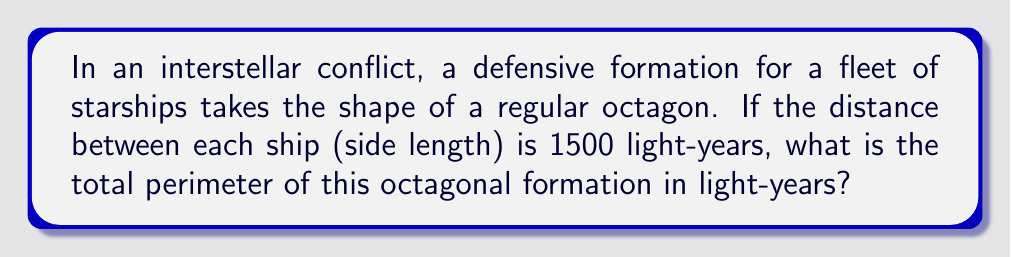Could you help me with this problem? Let's approach this step-by-step:

1) First, recall that a regular octagon has 8 equal sides.

2) The perimeter of any polygon is the sum of the lengths of all its sides.

3) For a regular polygon, we can calculate the perimeter by multiplying the length of one side by the number of sides:

   $$\text{Perimeter} = \text{Number of sides} \times \text{Side length}$$

4) In this case:
   - Number of sides = 8
   - Side length = 1500 light-years

5) Substituting these values into our formula:

   $$\text{Perimeter} = 8 \times 1500$$

6) Calculating:

   $$\text{Perimeter} = 12000 \text{ light-years}$$

Thus, the total perimeter of the octagonal defensive formation is 12000 light-years.
Answer: 12000 light-years 